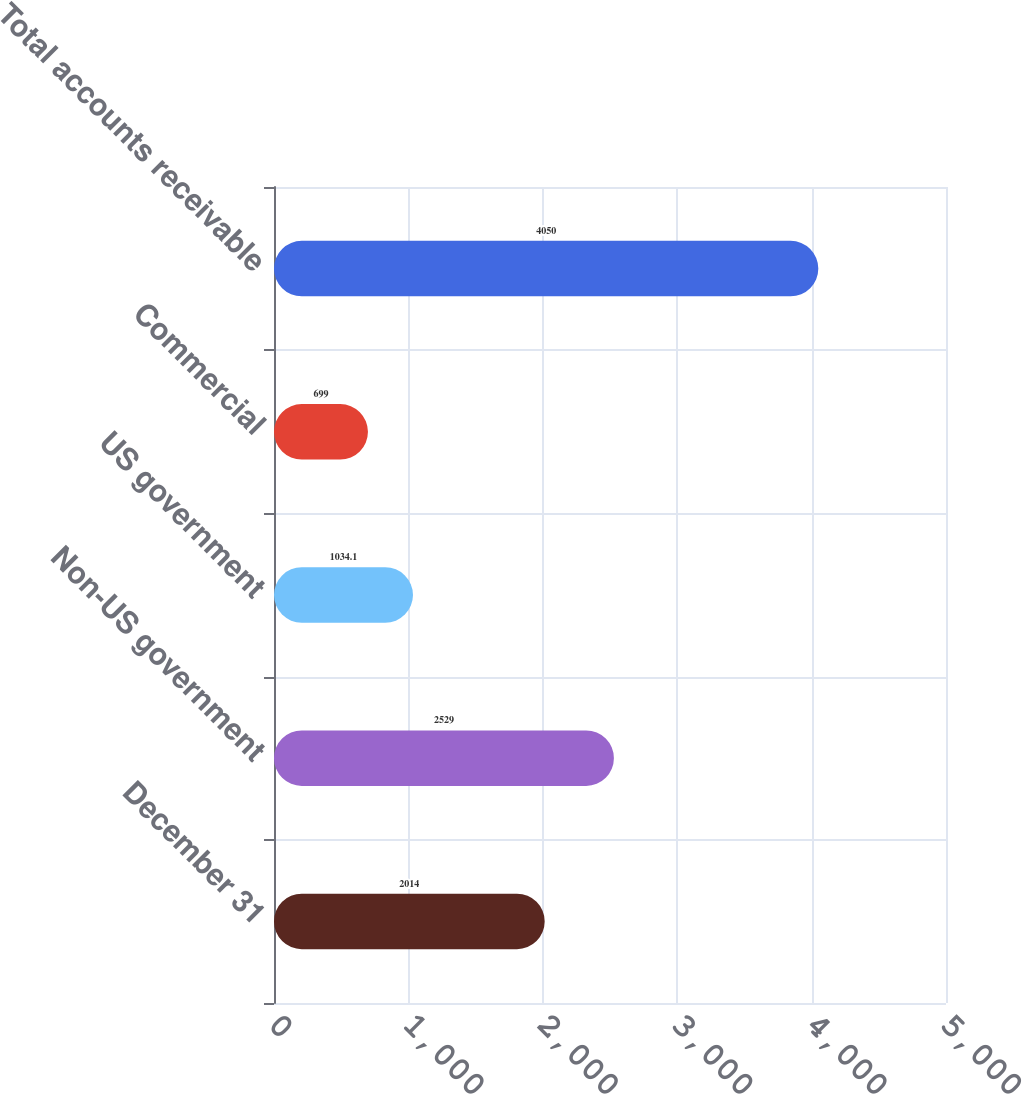Convert chart. <chart><loc_0><loc_0><loc_500><loc_500><bar_chart><fcel>December 31<fcel>Non-US government<fcel>US government<fcel>Commercial<fcel>Total accounts receivable<nl><fcel>2014<fcel>2529<fcel>1034.1<fcel>699<fcel>4050<nl></chart> 